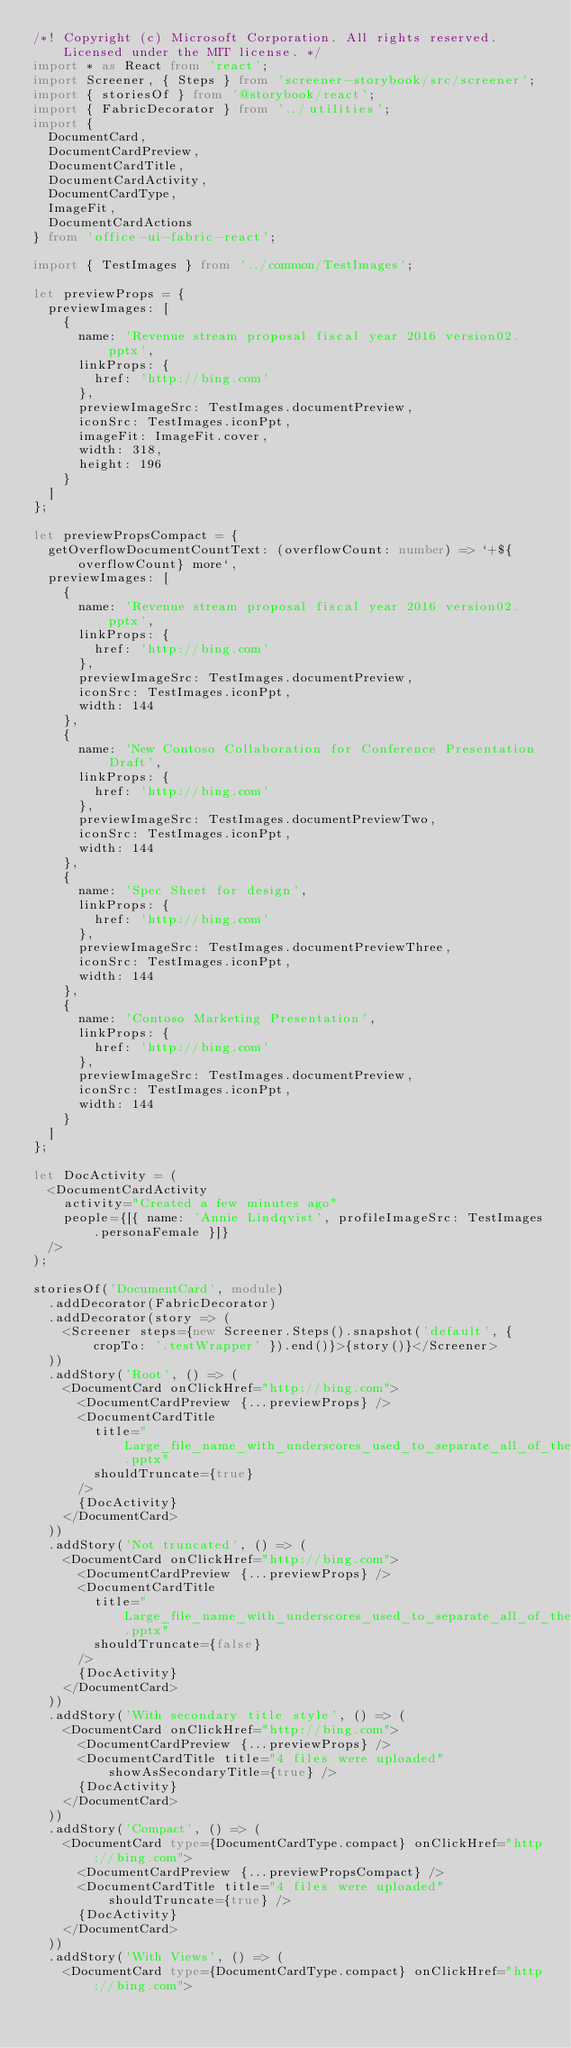<code> <loc_0><loc_0><loc_500><loc_500><_TypeScript_>/*! Copyright (c) Microsoft Corporation. All rights reserved. Licensed under the MIT license. */
import * as React from 'react';
import Screener, { Steps } from 'screener-storybook/src/screener';
import { storiesOf } from '@storybook/react';
import { FabricDecorator } from '../utilities';
import {
  DocumentCard,
  DocumentCardPreview,
  DocumentCardTitle,
  DocumentCardActivity,
  DocumentCardType,
  ImageFit,
  DocumentCardActions
} from 'office-ui-fabric-react';

import { TestImages } from '../common/TestImages';

let previewProps = {
  previewImages: [
    {
      name: 'Revenue stream proposal fiscal year 2016 version02.pptx',
      linkProps: {
        href: 'http://bing.com'
      },
      previewImageSrc: TestImages.documentPreview,
      iconSrc: TestImages.iconPpt,
      imageFit: ImageFit.cover,
      width: 318,
      height: 196
    }
  ]
};

let previewPropsCompact = {
  getOverflowDocumentCountText: (overflowCount: number) => `+${overflowCount} more`,
  previewImages: [
    {
      name: 'Revenue stream proposal fiscal year 2016 version02.pptx',
      linkProps: {
        href: 'http://bing.com'
      },
      previewImageSrc: TestImages.documentPreview,
      iconSrc: TestImages.iconPpt,
      width: 144
    },
    {
      name: 'New Contoso Collaboration for Conference Presentation Draft',
      linkProps: {
        href: 'http://bing.com'
      },
      previewImageSrc: TestImages.documentPreviewTwo,
      iconSrc: TestImages.iconPpt,
      width: 144
    },
    {
      name: 'Spec Sheet for design',
      linkProps: {
        href: 'http://bing.com'
      },
      previewImageSrc: TestImages.documentPreviewThree,
      iconSrc: TestImages.iconPpt,
      width: 144
    },
    {
      name: 'Contoso Marketing Presentation',
      linkProps: {
        href: 'http://bing.com'
      },
      previewImageSrc: TestImages.documentPreview,
      iconSrc: TestImages.iconPpt,
      width: 144
    }
  ]
};

let DocActivity = (
  <DocumentCardActivity
    activity="Created a few minutes ago"
    people={[{ name: 'Annie Lindqvist', profileImageSrc: TestImages.personaFemale }]}
  />
);

storiesOf('DocumentCard', module)
  .addDecorator(FabricDecorator)
  .addDecorator(story => (
    <Screener steps={new Screener.Steps().snapshot('default', { cropTo: '.testWrapper' }).end()}>{story()}</Screener>
  ))
  .addStory('Root', () => (
    <DocumentCard onClickHref="http://bing.com">
      <DocumentCardPreview {...previewProps} />
      <DocumentCardTitle
        title="Large_file_name_with_underscores_used_to_separate_all_of_the_words_and_there_are_so_many_words_it_needs_truncating.pptx"
        shouldTruncate={true}
      />
      {DocActivity}
    </DocumentCard>
  ))
  .addStory('Not truncated', () => (
    <DocumentCard onClickHref="http://bing.com">
      <DocumentCardPreview {...previewProps} />
      <DocumentCardTitle
        title="Large_file_name_with_underscores_used_to_separate_all_of_the_words_and_there_are_so_many_words_it_needs_truncating.pptx"
        shouldTruncate={false}
      />
      {DocActivity}
    </DocumentCard>
  ))
  .addStory('With secondary title style', () => (
    <DocumentCard onClickHref="http://bing.com">
      <DocumentCardPreview {...previewProps} />
      <DocumentCardTitle title="4 files were uploaded" showAsSecondaryTitle={true} />
      {DocActivity}
    </DocumentCard>
  ))
  .addStory('Compact', () => (
    <DocumentCard type={DocumentCardType.compact} onClickHref="http://bing.com">
      <DocumentCardPreview {...previewPropsCompact} />
      <DocumentCardTitle title="4 files were uploaded" shouldTruncate={true} />
      {DocActivity}
    </DocumentCard>
  ))
  .addStory('With Views', () => (
    <DocumentCard type={DocumentCardType.compact} onClickHref="http://bing.com"></code> 